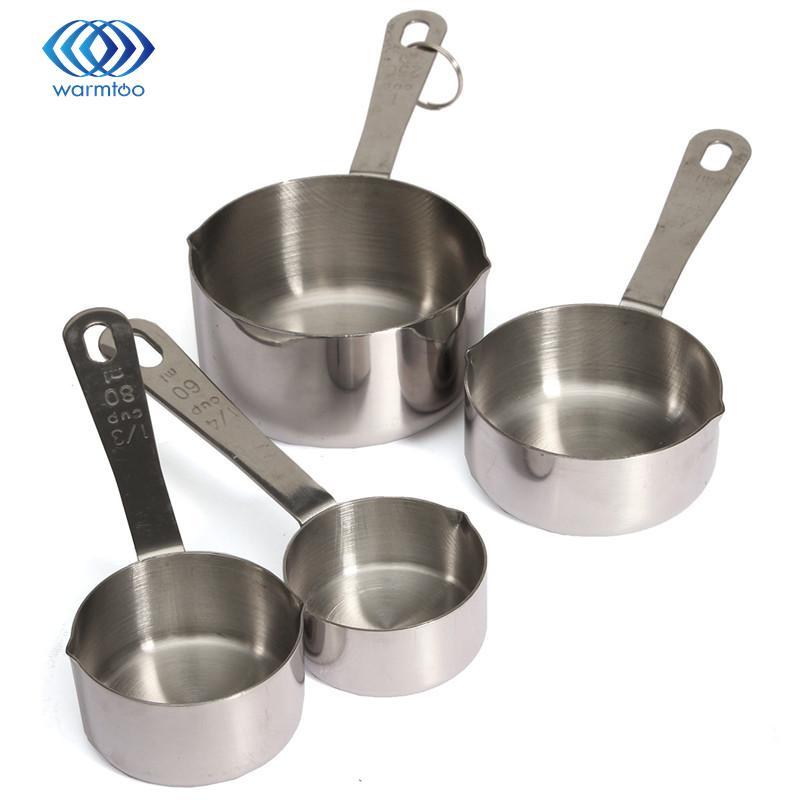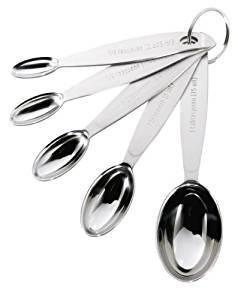The first image is the image on the left, the second image is the image on the right. Given the left and right images, does the statement "There are five measuring cups in the right image" hold true? Answer yes or no. Yes. 